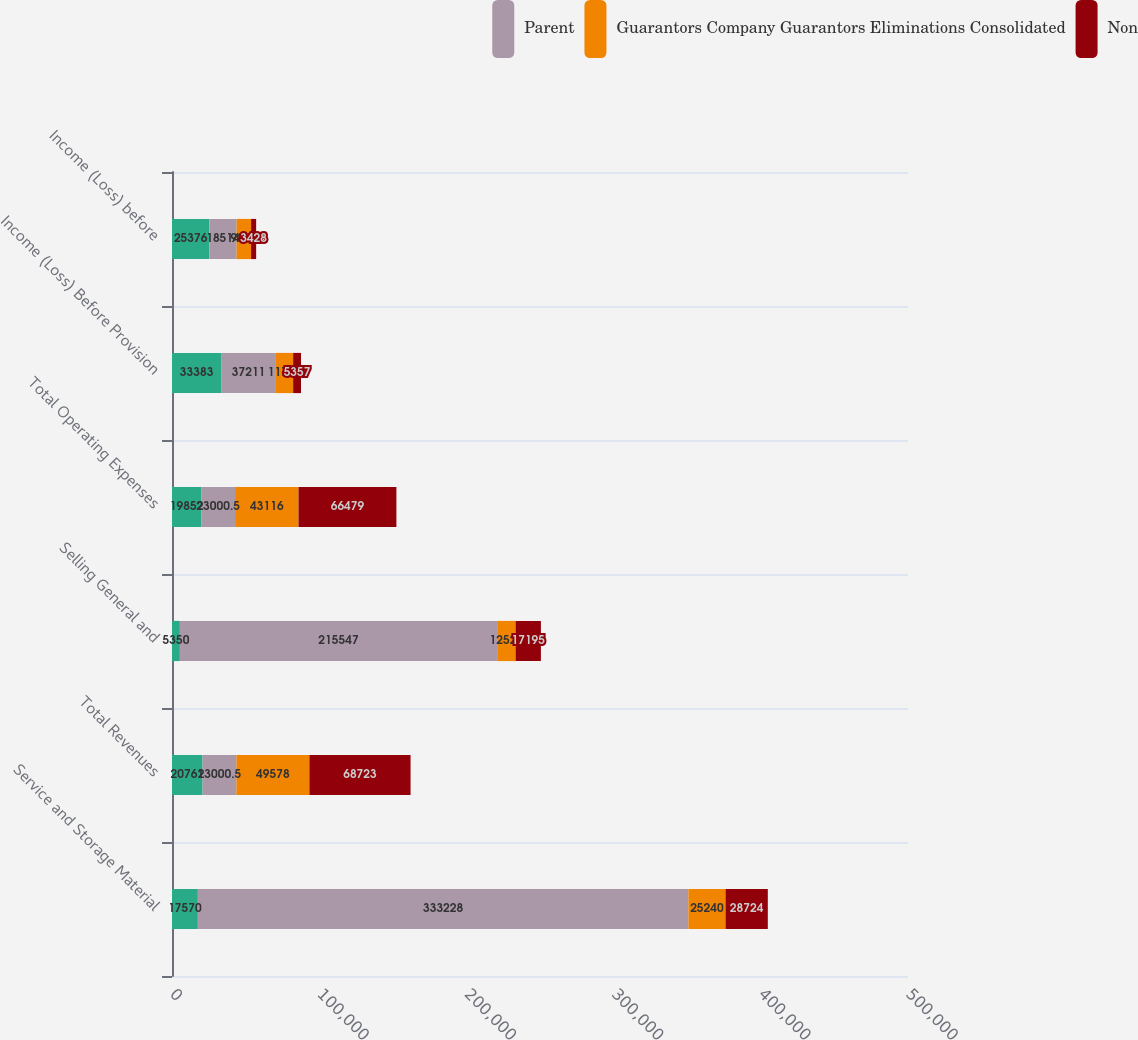<chart> <loc_0><loc_0><loc_500><loc_500><stacked_bar_chart><ecel><fcel>Service and Storage Material<fcel>Total Revenues<fcel>Selling General and<fcel>Total Operating Expenses<fcel>Income (Loss) Before Provision<fcel>Income (Loss) before<nl><fcel>nan<fcel>17570<fcel>20761<fcel>5350<fcel>19852<fcel>33383<fcel>25376<nl><fcel>Parent<fcel>333228<fcel>23000.5<fcel>215547<fcel>23000.5<fcel>37211<fcel>18514<nl><fcel>Guarantors Company Guarantors Eliminations Consolidated<fcel>25240<fcel>49578<fcel>12522<fcel>43116<fcel>11704<fcel>9844<nl><fcel>Non<fcel>28724<fcel>68723<fcel>17195<fcel>66479<fcel>5357<fcel>3428<nl></chart> 